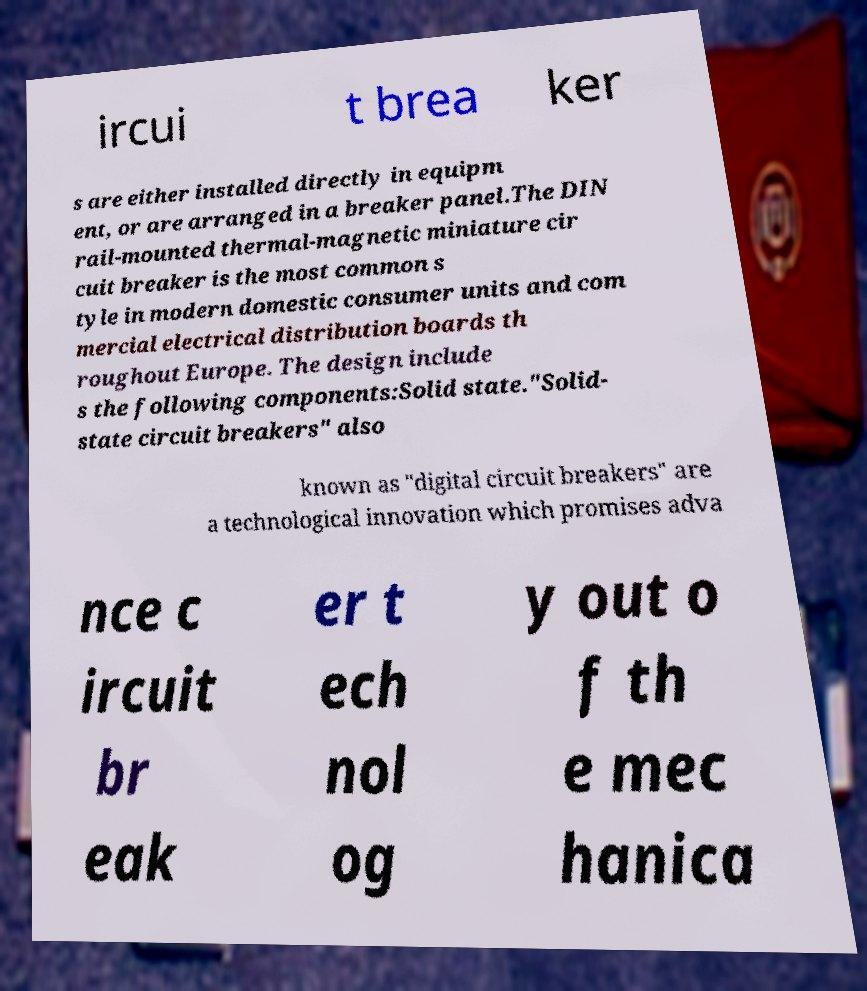Could you extract and type out the text from this image? ircui t brea ker s are either installed directly in equipm ent, or are arranged in a breaker panel.The DIN rail-mounted thermal-magnetic miniature cir cuit breaker is the most common s tyle in modern domestic consumer units and com mercial electrical distribution boards th roughout Europe. The design include s the following components:Solid state."Solid- state circuit breakers" also known as "digital circuit breakers" are a technological innovation which promises adva nce c ircuit br eak er t ech nol og y out o f th e mec hanica 